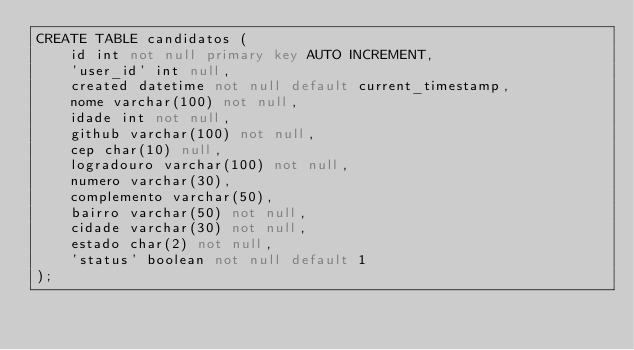Convert code to text. <code><loc_0><loc_0><loc_500><loc_500><_SQL_>CREATE TABLE candidatos (
    id int not null primary key AUTO INCREMENT,
	'user_id' int null,
    created datetime not null default current_timestamp,
    nome varchar(100) not null,
    idade int not null,
    github varchar(100) not null,
    cep char(10) null,
    logradouro varchar(100) not null,
    numero varchar(30),
    complemento varchar(50),
    bairro varchar(50) not null,
    cidade varchar(30) not null,
    estado char(2) not null,
    'status' boolean not null default 1
);
</code> 